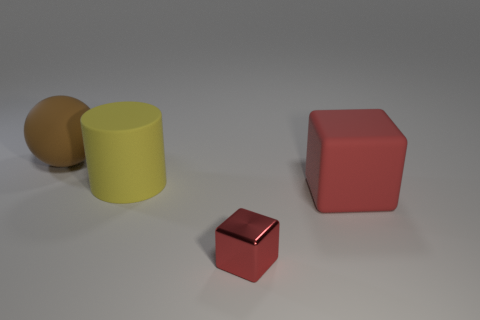What is the lighting situation in the image? The lighting in the image is subtle and diffused, suggesting an indoor setting with a single overhead light source casting soft shadows beneath each object. 